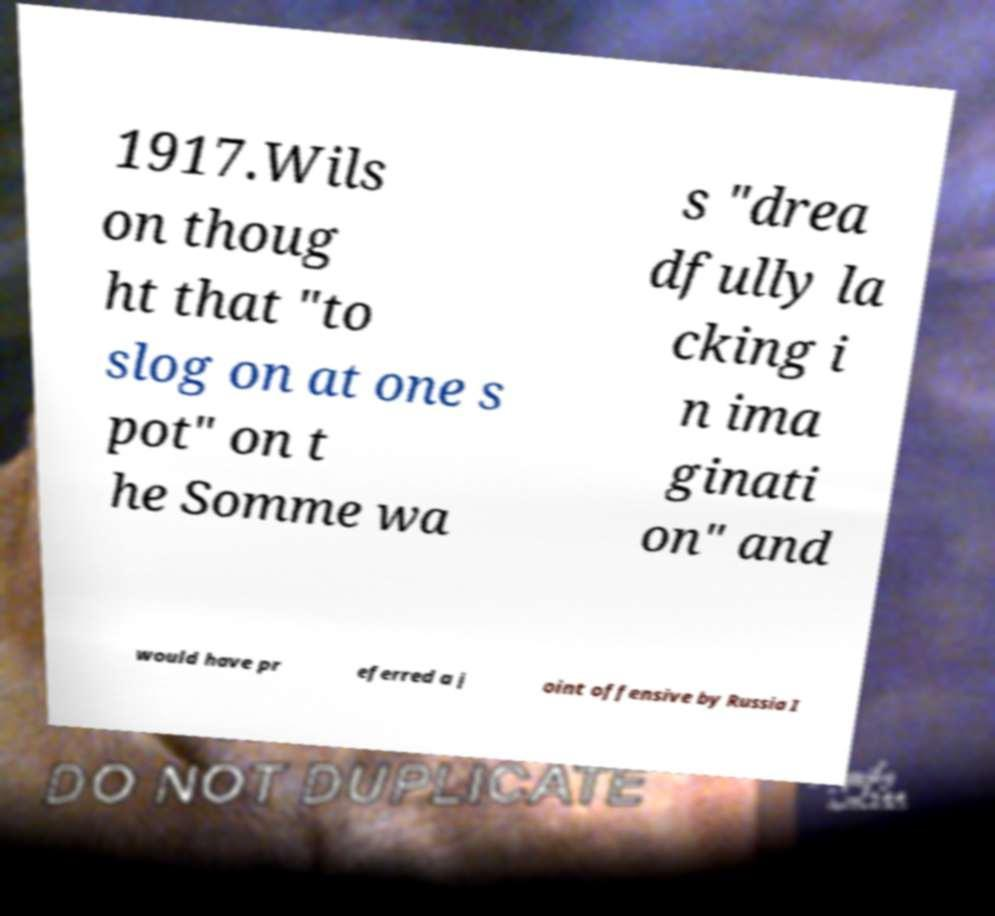Please identify and transcribe the text found in this image. 1917.Wils on thoug ht that "to slog on at one s pot" on t he Somme wa s "drea dfully la cking i n ima ginati on" and would have pr eferred a j oint offensive by Russia I 